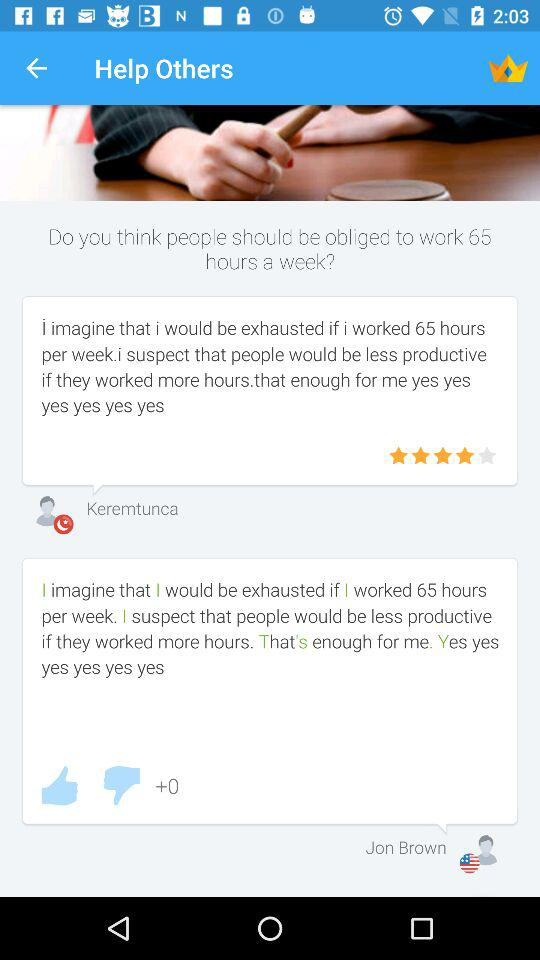What is the rating? The rating is 4 stars. 